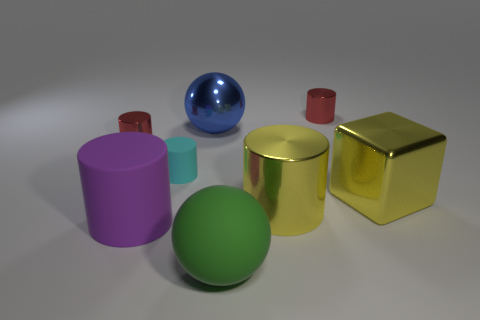Is there a green sphere that is to the left of the large yellow metal thing on the right side of the metallic cylinder behind the blue metal ball?
Offer a very short reply. Yes. How many other small cyan cylinders have the same material as the tiny cyan cylinder?
Offer a terse response. 0. Do the red cylinder that is on the left side of the small matte thing and the yellow metallic block to the right of the small cyan cylinder have the same size?
Offer a terse response. No. The large metallic thing behind the tiny red cylinder that is in front of the tiny cylinder that is on the right side of the big green rubber sphere is what color?
Offer a terse response. Blue. Is there a yellow thing that has the same shape as the small cyan rubber object?
Ensure brevity in your answer.  Yes. Are there the same number of rubber things that are on the right side of the tiny cyan matte object and big metallic cylinders that are to the right of the large blue metal object?
Your answer should be compact. Yes. There is a object in front of the purple rubber object; does it have the same shape as the blue shiny thing?
Ensure brevity in your answer.  Yes. Is the shape of the tiny cyan matte object the same as the purple object?
Keep it short and to the point. Yes. How many rubber things are big purple cylinders or large yellow blocks?
Ensure brevity in your answer.  1. Does the metal cube have the same size as the purple thing?
Your answer should be very brief. Yes. 